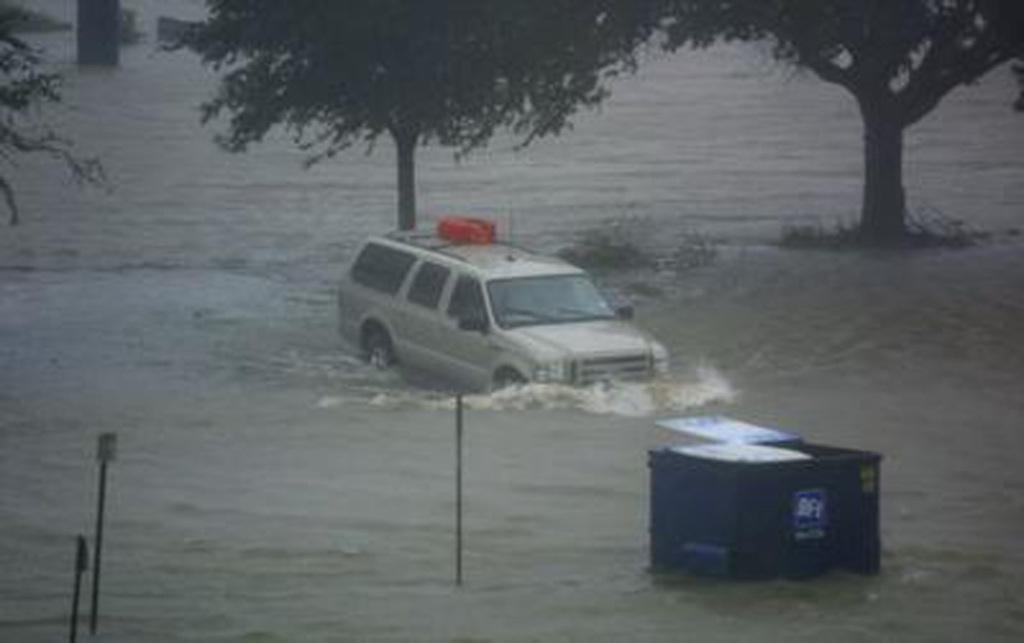Describe this image in one or two sentences. In this image I can see the water. I can see few black colored poles, a vehicle and a blue colored object in the water. 